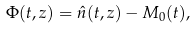<formula> <loc_0><loc_0><loc_500><loc_500>\Phi ( t , z ) = \hat { n } ( t , z ) - M _ { 0 } ( t ) ,</formula> 